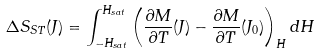<formula> <loc_0><loc_0><loc_500><loc_500>\Delta S _ { S T } ( J ) = \int _ { - H _ { s a t } } ^ { H _ { s a t } } \left ( \frac { \partial M } { \partial T } ( J ) - \frac { \partial M } { \partial T } ( J _ { 0 } ) \right ) _ { H } d H</formula> 